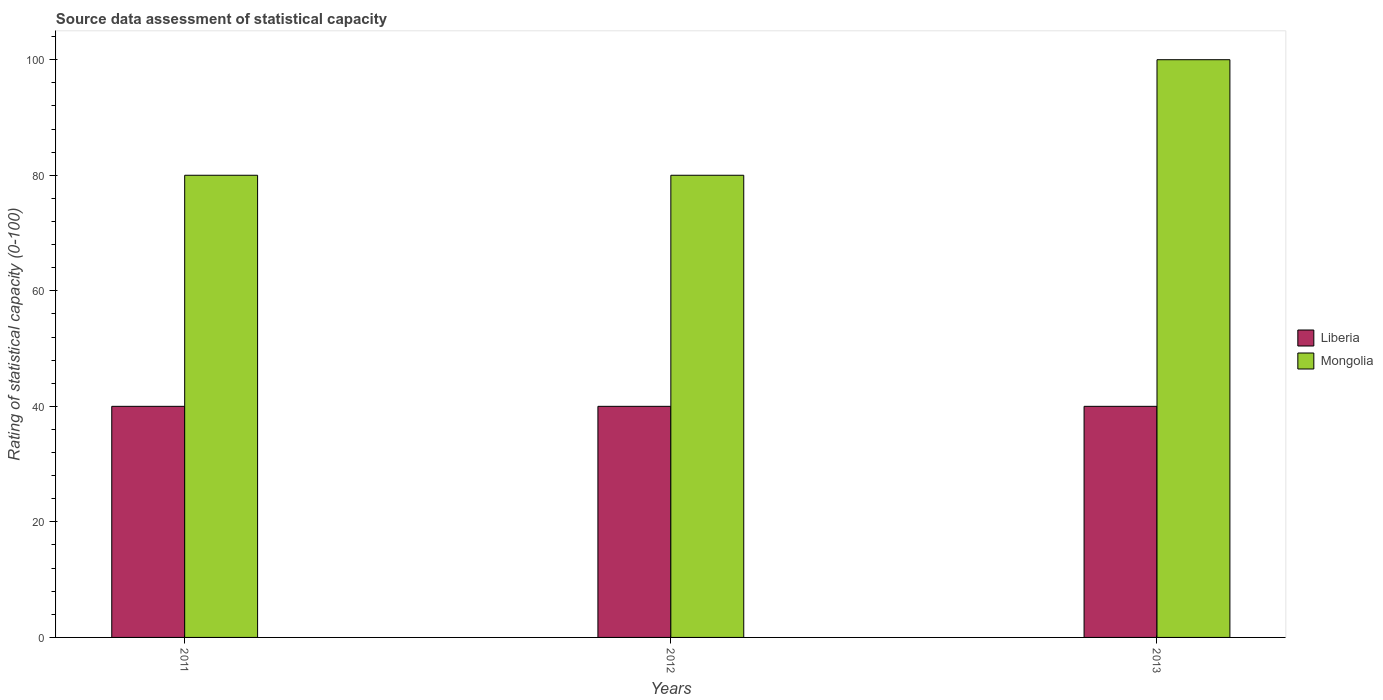How many different coloured bars are there?
Give a very brief answer. 2. Are the number of bars per tick equal to the number of legend labels?
Keep it short and to the point. Yes. Are the number of bars on each tick of the X-axis equal?
Your answer should be compact. Yes. How many bars are there on the 1st tick from the right?
Your answer should be very brief. 2. What is the label of the 3rd group of bars from the left?
Offer a very short reply. 2013. What is the rating of statistical capacity in Liberia in 2011?
Offer a very short reply. 40. Across all years, what is the maximum rating of statistical capacity in Mongolia?
Provide a short and direct response. 100. Across all years, what is the minimum rating of statistical capacity in Liberia?
Your answer should be very brief. 40. In which year was the rating of statistical capacity in Liberia minimum?
Make the answer very short. 2011. What is the total rating of statistical capacity in Liberia in the graph?
Ensure brevity in your answer.  120. What is the difference between the rating of statistical capacity in Liberia in 2011 and that in 2012?
Offer a very short reply. 0. What is the difference between the rating of statistical capacity in Mongolia in 2011 and the rating of statistical capacity in Liberia in 2013?
Offer a terse response. 40. What is the average rating of statistical capacity in Mongolia per year?
Give a very brief answer. 86.67. In the year 2012, what is the difference between the rating of statistical capacity in Liberia and rating of statistical capacity in Mongolia?
Provide a short and direct response. -40. Is the rating of statistical capacity in Mongolia in 2011 less than that in 2012?
Offer a very short reply. No. Is the difference between the rating of statistical capacity in Liberia in 2011 and 2012 greater than the difference between the rating of statistical capacity in Mongolia in 2011 and 2012?
Ensure brevity in your answer.  No. What is the difference between the highest and the second highest rating of statistical capacity in Mongolia?
Your response must be concise. 20. What is the difference between the highest and the lowest rating of statistical capacity in Liberia?
Provide a succinct answer. 0. In how many years, is the rating of statistical capacity in Liberia greater than the average rating of statistical capacity in Liberia taken over all years?
Your answer should be compact. 0. Is the sum of the rating of statistical capacity in Liberia in 2011 and 2012 greater than the maximum rating of statistical capacity in Mongolia across all years?
Provide a short and direct response. No. What does the 1st bar from the left in 2011 represents?
Give a very brief answer. Liberia. What does the 2nd bar from the right in 2011 represents?
Ensure brevity in your answer.  Liberia. How many bars are there?
Your answer should be compact. 6. Are all the bars in the graph horizontal?
Your answer should be compact. No. How many years are there in the graph?
Provide a succinct answer. 3. What is the difference between two consecutive major ticks on the Y-axis?
Offer a very short reply. 20. Are the values on the major ticks of Y-axis written in scientific E-notation?
Offer a very short reply. No. Where does the legend appear in the graph?
Provide a short and direct response. Center right. How many legend labels are there?
Your response must be concise. 2. How are the legend labels stacked?
Provide a succinct answer. Vertical. What is the title of the graph?
Offer a terse response. Source data assessment of statistical capacity. Does "American Samoa" appear as one of the legend labels in the graph?
Make the answer very short. No. What is the label or title of the X-axis?
Your answer should be compact. Years. What is the label or title of the Y-axis?
Make the answer very short. Rating of statistical capacity (0-100). What is the Rating of statistical capacity (0-100) in Mongolia in 2013?
Keep it short and to the point. 100. Across all years, what is the maximum Rating of statistical capacity (0-100) in Liberia?
Offer a terse response. 40. Across all years, what is the maximum Rating of statistical capacity (0-100) of Mongolia?
Your answer should be very brief. 100. Across all years, what is the minimum Rating of statistical capacity (0-100) of Mongolia?
Ensure brevity in your answer.  80. What is the total Rating of statistical capacity (0-100) of Liberia in the graph?
Provide a succinct answer. 120. What is the total Rating of statistical capacity (0-100) in Mongolia in the graph?
Offer a very short reply. 260. What is the difference between the Rating of statistical capacity (0-100) in Liberia in 2011 and that in 2013?
Provide a succinct answer. 0. What is the difference between the Rating of statistical capacity (0-100) of Liberia in 2012 and that in 2013?
Offer a terse response. 0. What is the difference between the Rating of statistical capacity (0-100) of Liberia in 2011 and the Rating of statistical capacity (0-100) of Mongolia in 2013?
Offer a very short reply. -60. What is the difference between the Rating of statistical capacity (0-100) in Liberia in 2012 and the Rating of statistical capacity (0-100) in Mongolia in 2013?
Your answer should be very brief. -60. What is the average Rating of statistical capacity (0-100) of Mongolia per year?
Give a very brief answer. 86.67. In the year 2013, what is the difference between the Rating of statistical capacity (0-100) in Liberia and Rating of statistical capacity (0-100) in Mongolia?
Ensure brevity in your answer.  -60. What is the ratio of the Rating of statistical capacity (0-100) of Liberia in 2011 to that in 2012?
Offer a very short reply. 1. What is the ratio of the Rating of statistical capacity (0-100) of Mongolia in 2011 to that in 2013?
Offer a terse response. 0.8. What is the ratio of the Rating of statistical capacity (0-100) in Liberia in 2012 to that in 2013?
Keep it short and to the point. 1. What is the ratio of the Rating of statistical capacity (0-100) of Mongolia in 2012 to that in 2013?
Provide a succinct answer. 0.8. What is the difference between the highest and the second highest Rating of statistical capacity (0-100) in Liberia?
Provide a succinct answer. 0. What is the difference between the highest and the second highest Rating of statistical capacity (0-100) of Mongolia?
Offer a very short reply. 20. What is the difference between the highest and the lowest Rating of statistical capacity (0-100) in Liberia?
Make the answer very short. 0. 